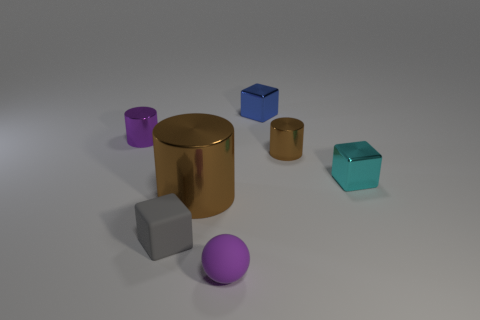Are there any cubes in front of the small purple matte ball?
Offer a terse response. No. There is a brown metallic cylinder that is on the left side of the tiny purple rubber ball; is there a sphere to the right of it?
Your answer should be very brief. Yes. Does the cyan metal block that is right of the purple ball have the same size as the purple object that is behind the gray object?
Provide a succinct answer. Yes. What number of small things are gray blocks or brown objects?
Provide a succinct answer. 2. What material is the small purple thing in front of the tiny purple metallic thing behind the small ball?
Provide a succinct answer. Rubber. Is there a small ball made of the same material as the large object?
Make the answer very short. No. Is the big brown cylinder made of the same material as the small block that is on the left side of the sphere?
Offer a terse response. No. What color is the sphere that is the same size as the cyan shiny thing?
Make the answer very short. Purple. What size is the metal cylinder that is in front of the brown object that is behind the big brown metal object?
Your response must be concise. Large. Is the color of the large metal cylinder the same as the tiny metallic cylinder that is on the right side of the small matte cube?
Make the answer very short. Yes. 